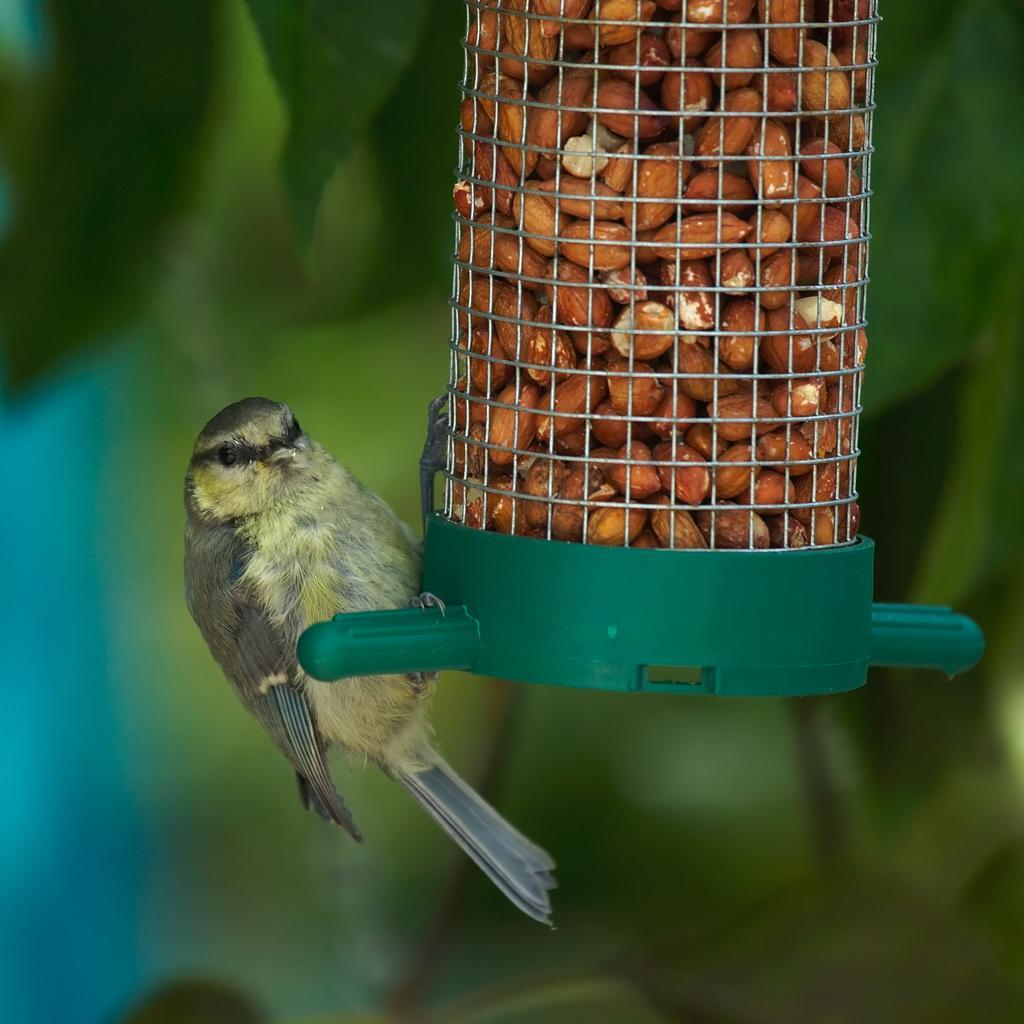In one or two sentences, can you explain what this image depicts? In this image I can see the bird in brown and cream color and I can also see the food in the cage. Background I can see few leaves in green color. 